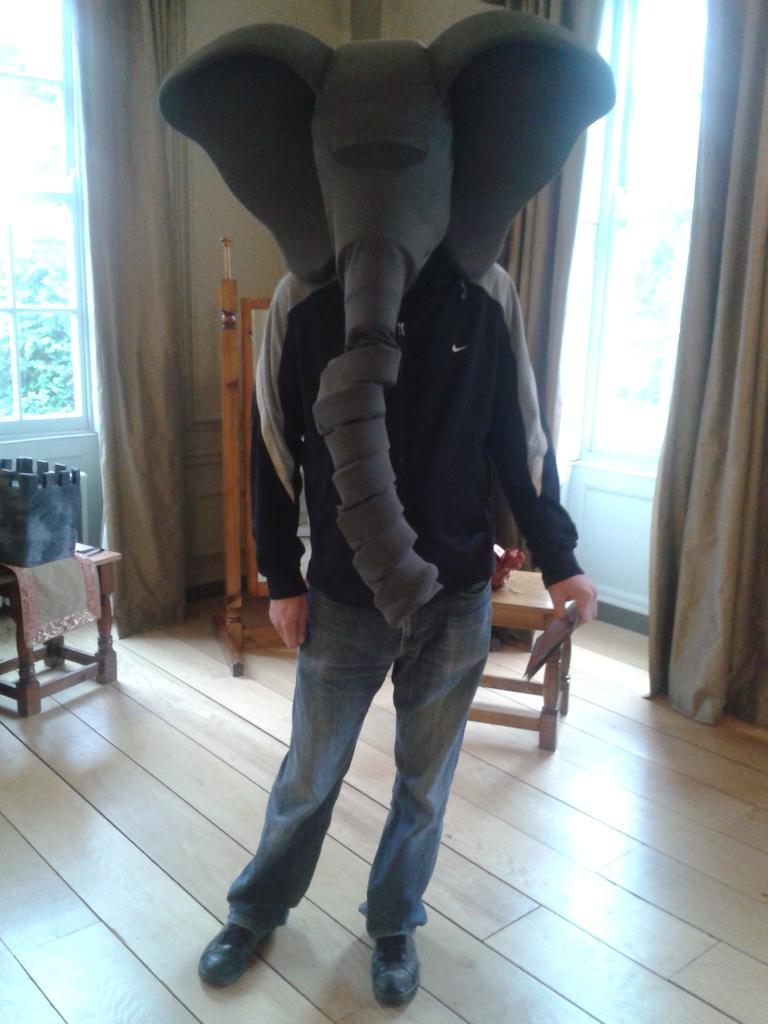Please provide a concise description of this image. In the middle there is a man he wear jacket , trouser and shoes. In the background there is a chair ,curtain ,window ,glass ,wall. I think this is a house ,On the left there is a stool and piece of cloth. 